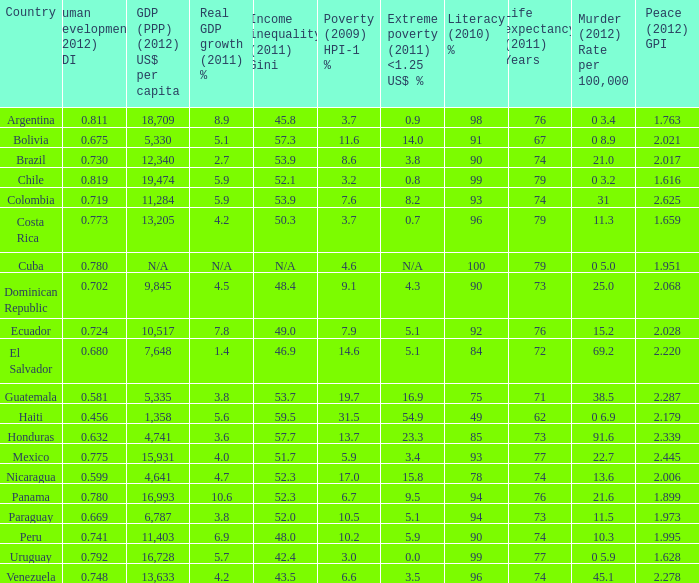I'm looking to parse the entire table for insights. Could you assist me with that? {'header': ['Country', 'Human development (2012) HDI', 'GDP (PPP) (2012) US$ per capita', 'Real GDP growth (2011) %', 'Income inequality (2011) Gini', 'Poverty (2009) HPI-1 %', 'Extreme poverty (2011) <1.25 US$ %', 'Literacy (2010) %', 'Life expectancy (2011) Years', 'Murder (2012) Rate per 100,000', 'Peace (2012) GPI'], 'rows': [['Argentina', '0.811', '18,709', '8.9', '45.8', '3.7', '0.9', '98', '76', '0 3.4', '1.763'], ['Bolivia', '0.675', '5,330', '5.1', '57.3', '11.6', '14.0', '91', '67', '0 8.9', '2.021'], ['Brazil', '0.730', '12,340', '2.7', '53.9', '8.6', '3.8', '90', '74', '21.0', '2.017'], ['Chile', '0.819', '19,474', '5.9', '52.1', '3.2', '0.8', '99', '79', '0 3.2', '1.616'], ['Colombia', '0.719', '11,284', '5.9', '53.9', '7.6', '8.2', '93', '74', '31', '2.625'], ['Costa Rica', '0.773', '13,205', '4.2', '50.3', '3.7', '0.7', '96', '79', '11.3', '1.659'], ['Cuba', '0.780', 'N/A', 'N/A', 'N/A', '4.6', 'N/A', '100', '79', '0 5.0', '1.951'], ['Dominican Republic', '0.702', '9,845', '4.5', '48.4', '9.1', '4.3', '90', '73', '25.0', '2.068'], ['Ecuador', '0.724', '10,517', '7.8', '49.0', '7.9', '5.1', '92', '76', '15.2', '2.028'], ['El Salvador', '0.680', '7,648', '1.4', '46.9', '14.6', '5.1', '84', '72', '69.2', '2.220'], ['Guatemala', '0.581', '5,335', '3.8', '53.7', '19.7', '16.9', '75', '71', '38.5', '2.287'], ['Haiti', '0.456', '1,358', '5.6', '59.5', '31.5', '54.9', '49', '62', '0 6.9', '2.179'], ['Honduras', '0.632', '4,741', '3.6', '57.7', '13.7', '23.3', '85', '73', '91.6', '2.339'], ['Mexico', '0.775', '15,931', '4.0', '51.7', '5.9', '3.4', '93', '77', '22.7', '2.445'], ['Nicaragua', '0.599', '4,641', '4.7', '52.3', '17.0', '15.8', '78', '74', '13.6', '2.006'], ['Panama', '0.780', '16,993', '10.6', '52.3', '6.7', '9.5', '94', '76', '21.6', '1.899'], ['Paraguay', '0.669', '6,787', '3.8', '52.0', '10.5', '5.1', '94', '73', '11.5', '1.973'], ['Peru', '0.741', '11,403', '6.9', '48.0', '10.2', '5.9', '90', '74', '10.3', '1.995'], ['Uruguay', '0.792', '16,728', '5.7', '42.4', '3.0', '0.0', '99', '77', '0 5.9', '1.628'], ['Venezuela', '0.748', '13,633', '4.2', '43.5', '6.6', '3.5', '96', '74', '45.1', '2.278']]} What is the combined percentage of poverty (2009) hpi-1 % when the gdp (ppp) (2012) us$ per capita equals 11,284? 1.0. 